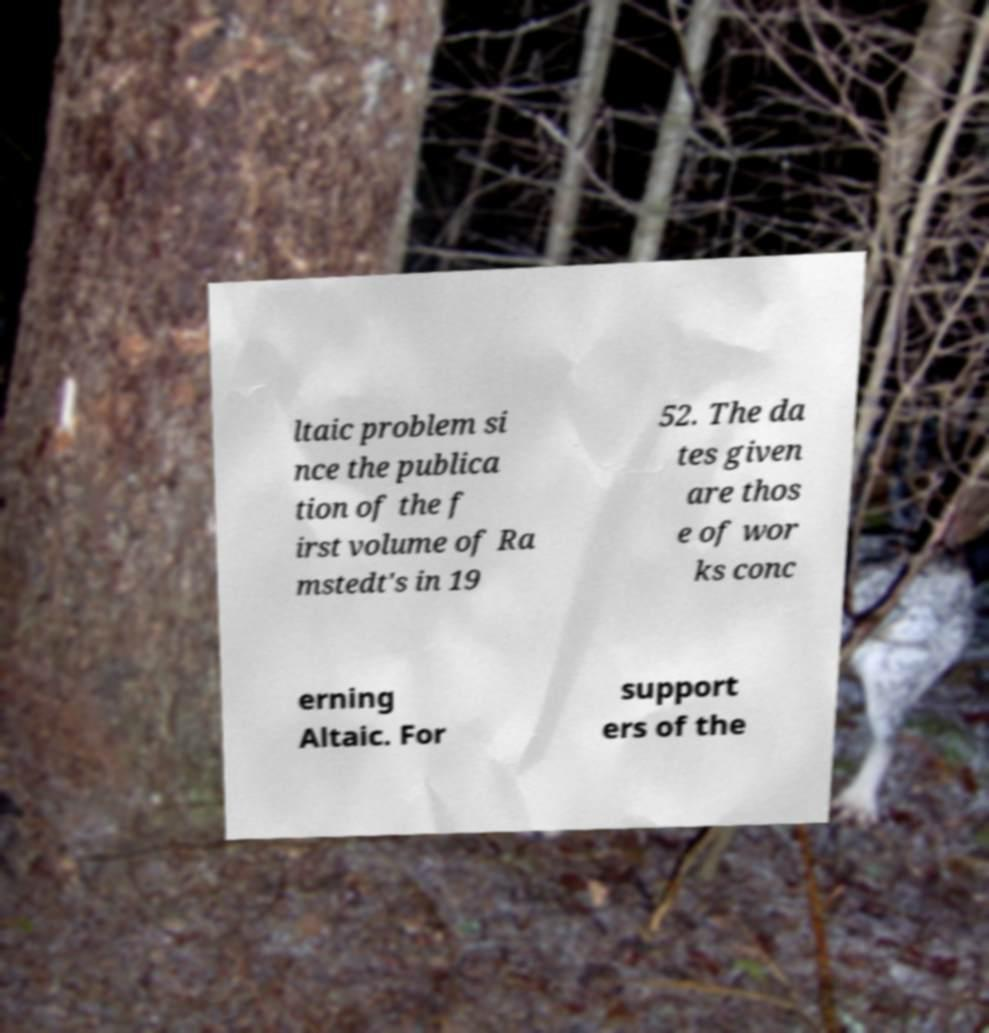Could you extract and type out the text from this image? ltaic problem si nce the publica tion of the f irst volume of Ra mstedt's in 19 52. The da tes given are thos e of wor ks conc erning Altaic. For support ers of the 